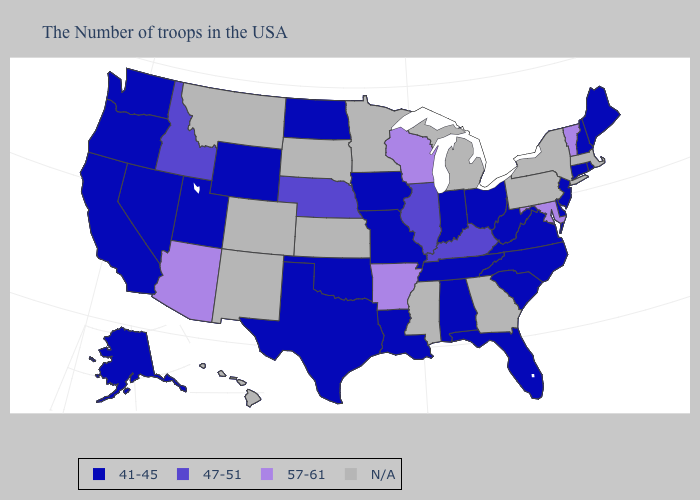What is the value of Wyoming?
Quick response, please. 41-45. What is the value of Louisiana?
Keep it brief. 41-45. What is the value of Georgia?
Be succinct. N/A. What is the highest value in the MidWest ?
Be succinct. 57-61. Name the states that have a value in the range N/A?
Answer briefly. Massachusetts, New York, Pennsylvania, Georgia, Michigan, Mississippi, Minnesota, Kansas, South Dakota, Colorado, New Mexico, Montana, Hawaii. Among the states that border Minnesota , which have the lowest value?
Keep it brief. Iowa, North Dakota. What is the value of North Carolina?
Give a very brief answer. 41-45. What is the value of Oregon?
Give a very brief answer. 41-45. What is the highest value in states that border Rhode Island?
Keep it brief. 41-45. Which states have the highest value in the USA?
Concise answer only. Vermont, Maryland, Wisconsin, Arkansas, Arizona. Name the states that have a value in the range 41-45?
Give a very brief answer. Maine, Rhode Island, New Hampshire, Connecticut, New Jersey, Delaware, Virginia, North Carolina, South Carolina, West Virginia, Ohio, Florida, Indiana, Alabama, Tennessee, Louisiana, Missouri, Iowa, Oklahoma, Texas, North Dakota, Wyoming, Utah, Nevada, California, Washington, Oregon, Alaska. Among the states that border Virginia , does West Virginia have the highest value?
Keep it brief. No. What is the highest value in states that border Kansas?
Answer briefly. 47-51. Which states have the highest value in the USA?
Answer briefly. Vermont, Maryland, Wisconsin, Arkansas, Arizona. Name the states that have a value in the range N/A?
Be succinct. Massachusetts, New York, Pennsylvania, Georgia, Michigan, Mississippi, Minnesota, Kansas, South Dakota, Colorado, New Mexico, Montana, Hawaii. 